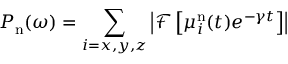Convert formula to latex. <formula><loc_0><loc_0><loc_500><loc_500>P _ { n } ( \omega ) = \sum _ { i = x , y , z } \left | \mathcal { F } \left [ \mu _ { i } ^ { n } ( t ) e ^ { - \gamma t } \right ] \right |</formula> 